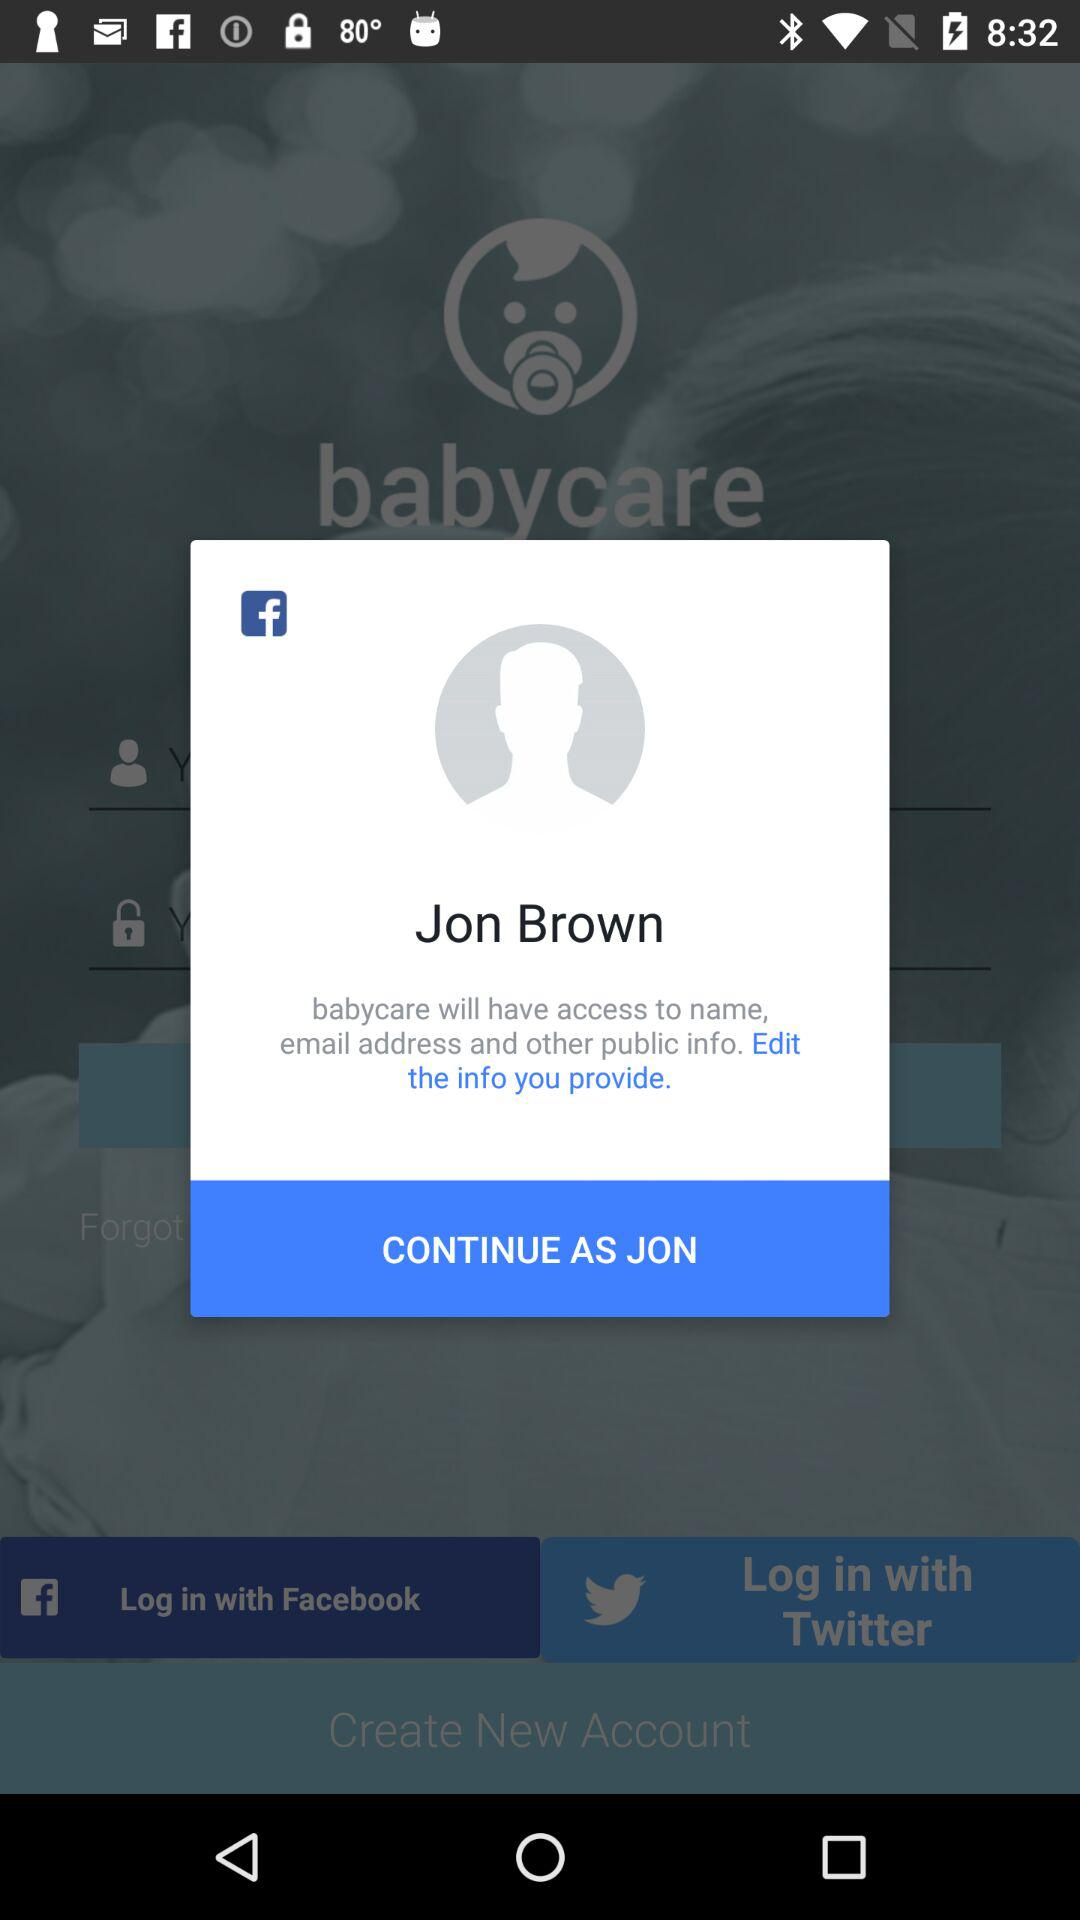What application is asking for permission? The application is "babycare". 